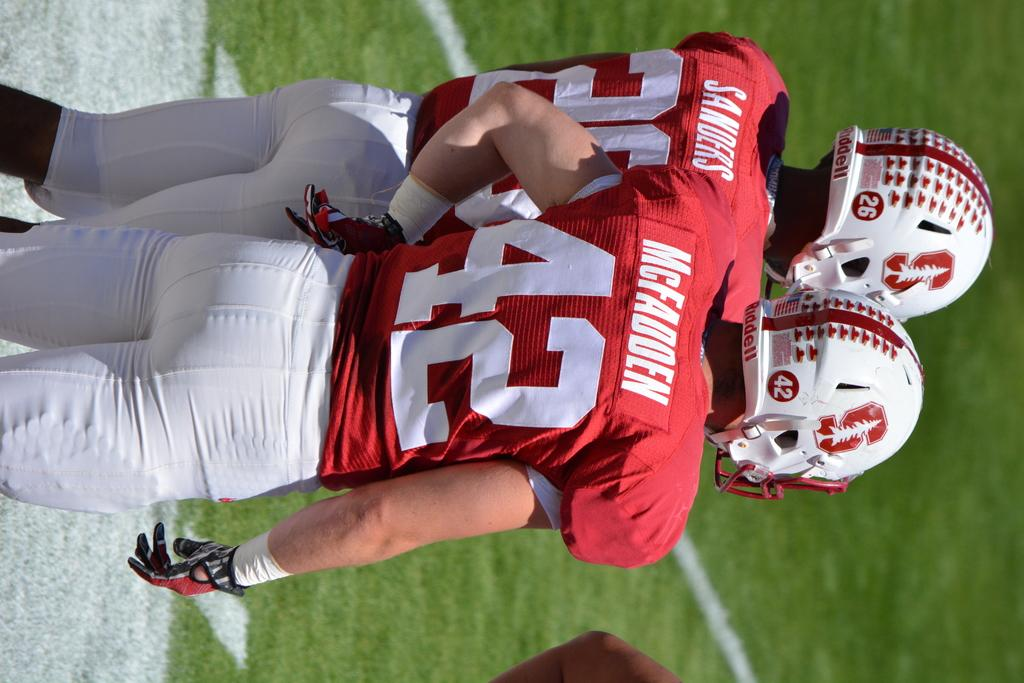How many people are in the image? There are two persons in the image. What are the people wearing? Both persons are wearing red and white dresses and helmets. What is the position of the persons in the image? The persons are on the ground. How many kittens can be seen playing with a structure in the image? There are no kittens or structures present in the image. What type of force is being applied by the persons in the image? The provided facts do not mention any force being applied by the persons in the image. 